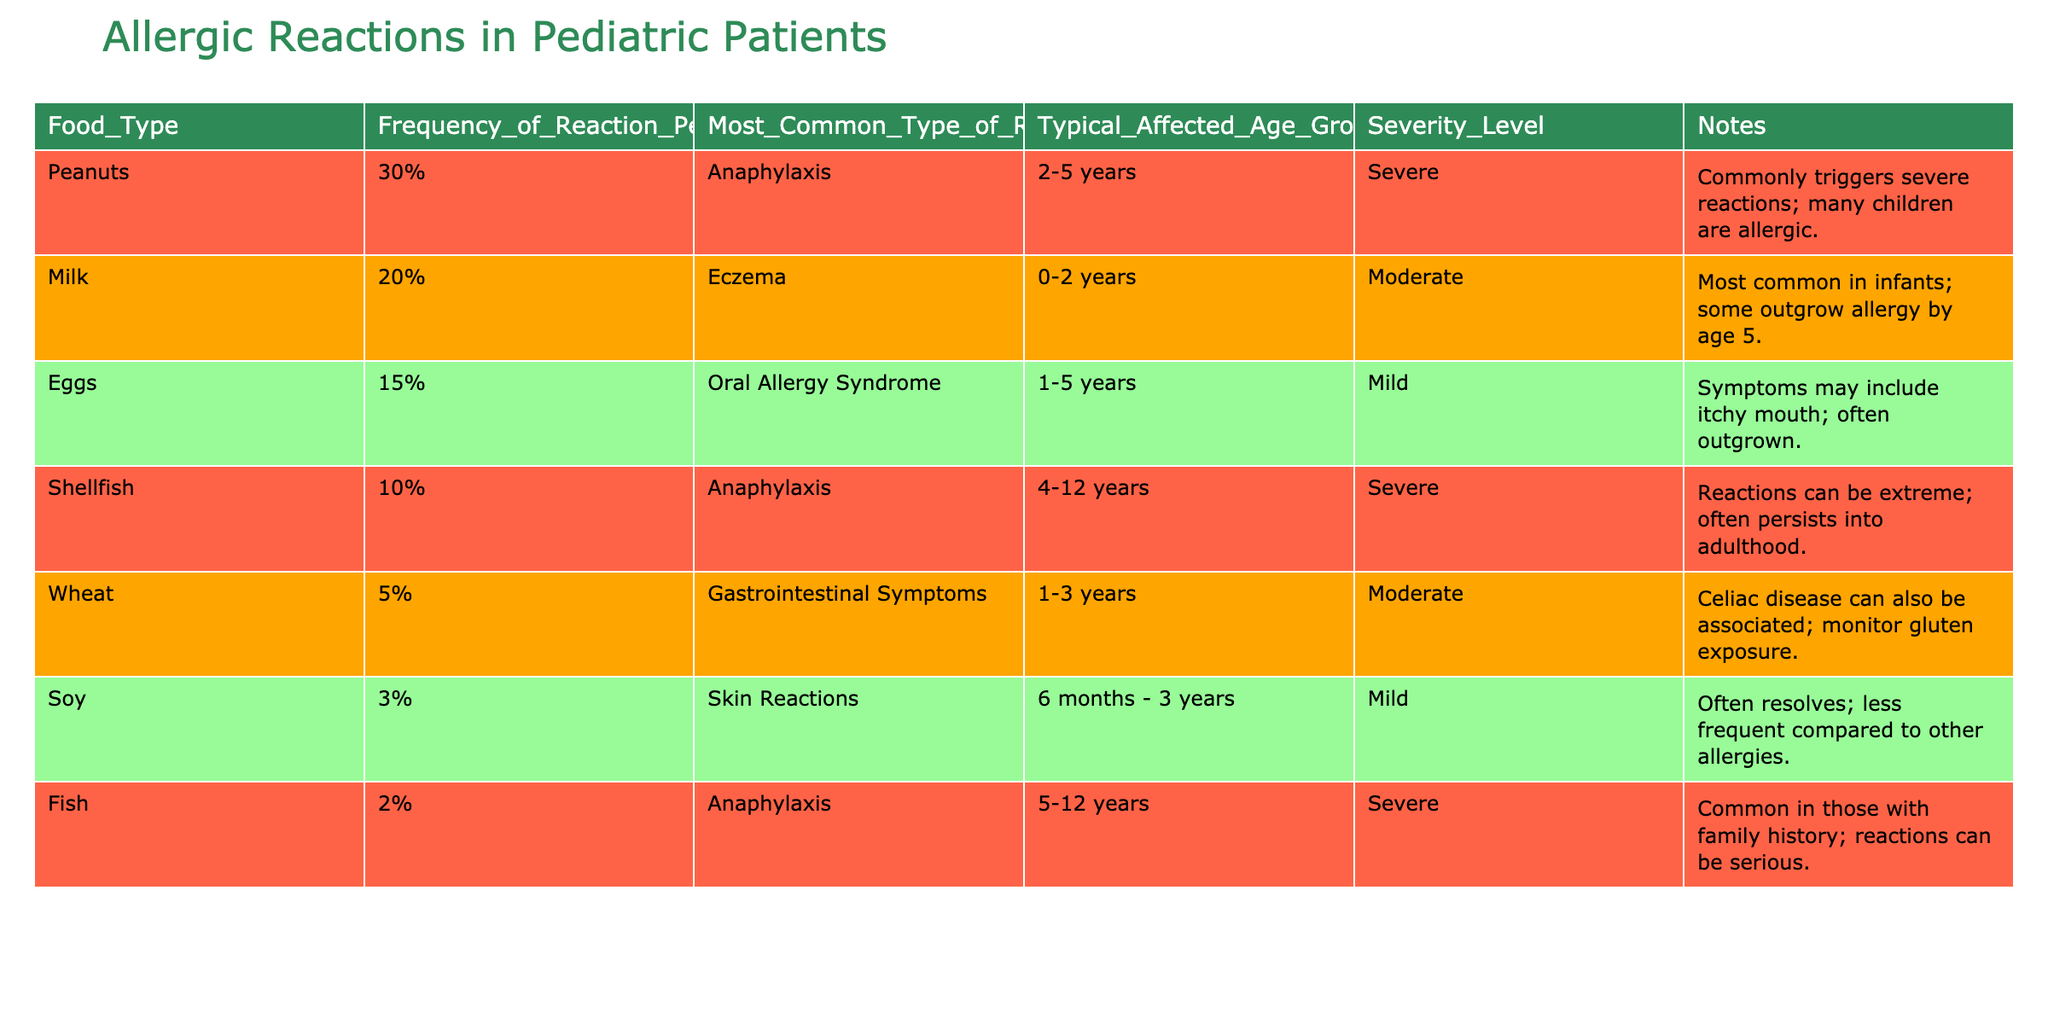What percentage of allergic reactions is associated with peanuts? The table indicates that peanuts account for 30% of allergic reactions, as stated in the "Frequency_of_Reaction_Percent" column.
Answer: 30% What is the most common type of allergic reaction for milk? According to the table, the most common type of reaction for milk is eczema, as mentioned in the "Most_Common_Type_of_Reaction" column next to milk.
Answer: Eczema How many food types have a severity level classified as severe? The table shows that peanuts, shellfish, and fish are classified as severe, giving a total of three food types with that severity level.
Answer: 3 What is the typical age group affected by allergic reactions to eggs? The table lists the typical age group affected by eggs as 1-5 years, referenced in the "Typical_Affected_Age_Group" column.
Answer: 1-5 years If the reactions to peanuts and shellfish are combined, what percentage of reactions does that represent? Peanuts account for 30% and shellfish 10%, so combining them gives 30% + 10% = 40%.
Answer: 40% Is it true that all the food types listed can cause severe allergic reactions? The table clearly states that only peanuts, shellfish, and fish are classified as causing severe allergic reactions, while others have moderate or mild severity, making the statement false.
Answer: False Which food type has the least frequency of allergic reactions? The table displays that fish has the least frequency of allergic reactions at 2%.
Answer: Fish What is the most frequent type of allergic reaction among the described foods? Peanuts have the highest frequency of allergic reactions at 30%, making it the most frequent type as stated in the "Frequency_of_Reaction_Percent" column.
Answer: Peanuts If 100 children are allergic to the food types listed, how many would be expected to react to wheat? Given that 5% of reactions are associated with wheat, we calculate 5% of 100 children, which results in 5 children expected to react.
Answer: 5 Which food type is most commonly associated with anaphylaxis? The table identifies both peanuts and shellfish as commonly associated with anaphylaxis, but peanuts have the highest frequency at 30%.
Answer: Peanuts 